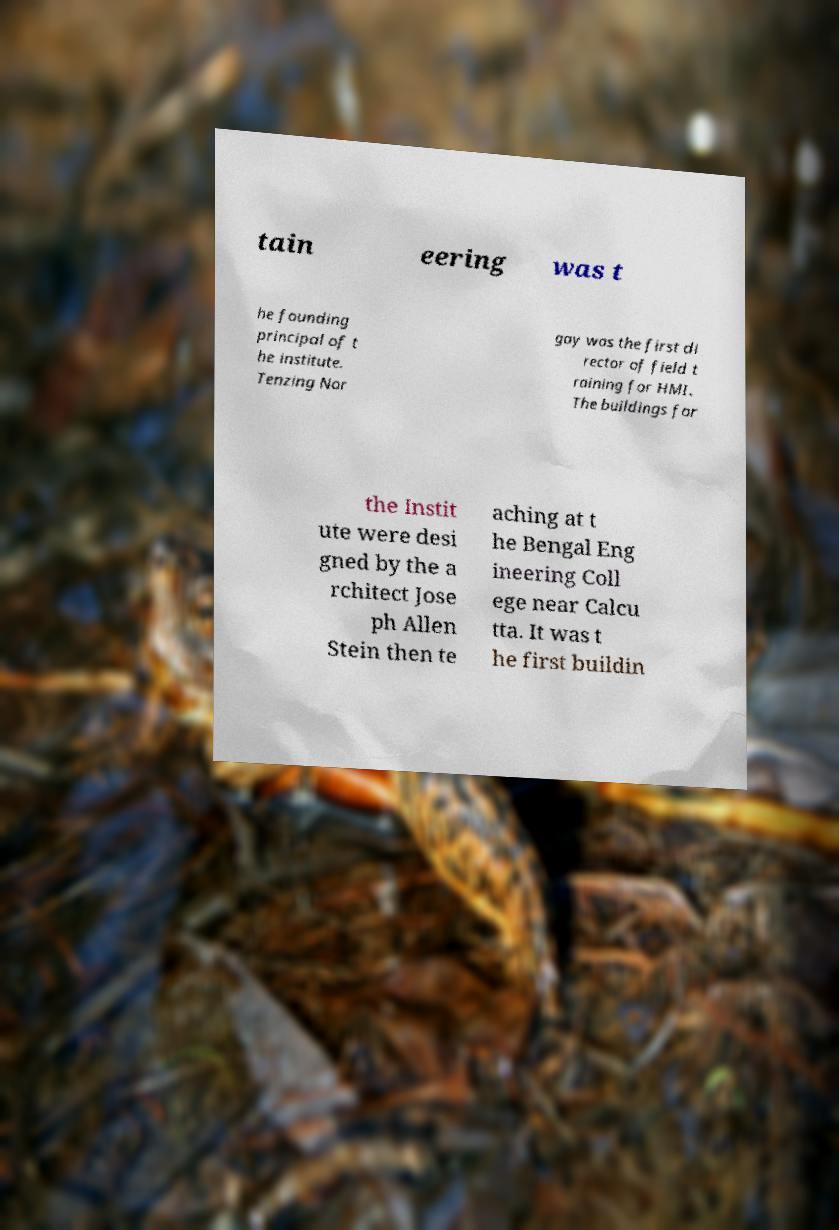There's text embedded in this image that I need extracted. Can you transcribe it verbatim? tain eering was t he founding principal of t he institute. Tenzing Nor gay was the first di rector of field t raining for HMI. The buildings for the Instit ute were desi gned by the a rchitect Jose ph Allen Stein then te aching at t he Bengal Eng ineering Coll ege near Calcu tta. It was t he first buildin 